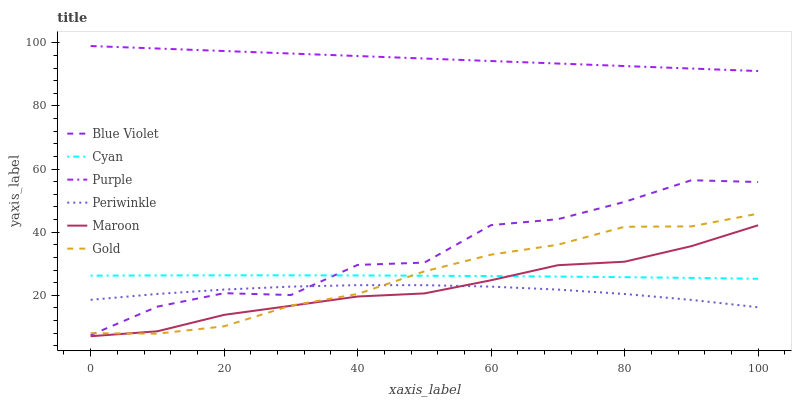Does Periwinkle have the minimum area under the curve?
Answer yes or no. Yes. Does Purple have the maximum area under the curve?
Answer yes or no. Yes. Does Maroon have the minimum area under the curve?
Answer yes or no. No. Does Maroon have the maximum area under the curve?
Answer yes or no. No. Is Purple the smoothest?
Answer yes or no. Yes. Is Blue Violet the roughest?
Answer yes or no. Yes. Is Maroon the smoothest?
Answer yes or no. No. Is Maroon the roughest?
Answer yes or no. No. Does Maroon have the lowest value?
Answer yes or no. Yes. Does Purple have the lowest value?
Answer yes or no. No. Does Purple have the highest value?
Answer yes or no. Yes. Does Maroon have the highest value?
Answer yes or no. No. Is Gold less than Purple?
Answer yes or no. Yes. Is Purple greater than Cyan?
Answer yes or no. Yes. Does Cyan intersect Maroon?
Answer yes or no. Yes. Is Cyan less than Maroon?
Answer yes or no. No. Is Cyan greater than Maroon?
Answer yes or no. No. Does Gold intersect Purple?
Answer yes or no. No. 